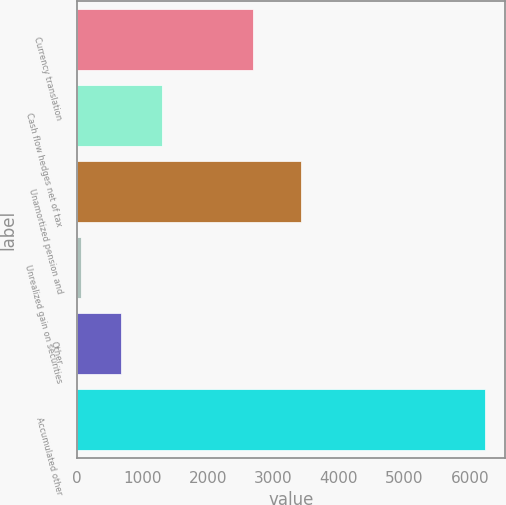Convert chart. <chart><loc_0><loc_0><loc_500><loc_500><bar_chart><fcel>Currency translation<fcel>Cash flow hedges net of tax<fcel>Unamortized pension and<fcel>Unrealized gain on securities<fcel>Other<fcel>Accumulated other<nl><fcel>2688<fcel>1295.4<fcel>3419<fcel>62<fcel>678.7<fcel>6229<nl></chart> 